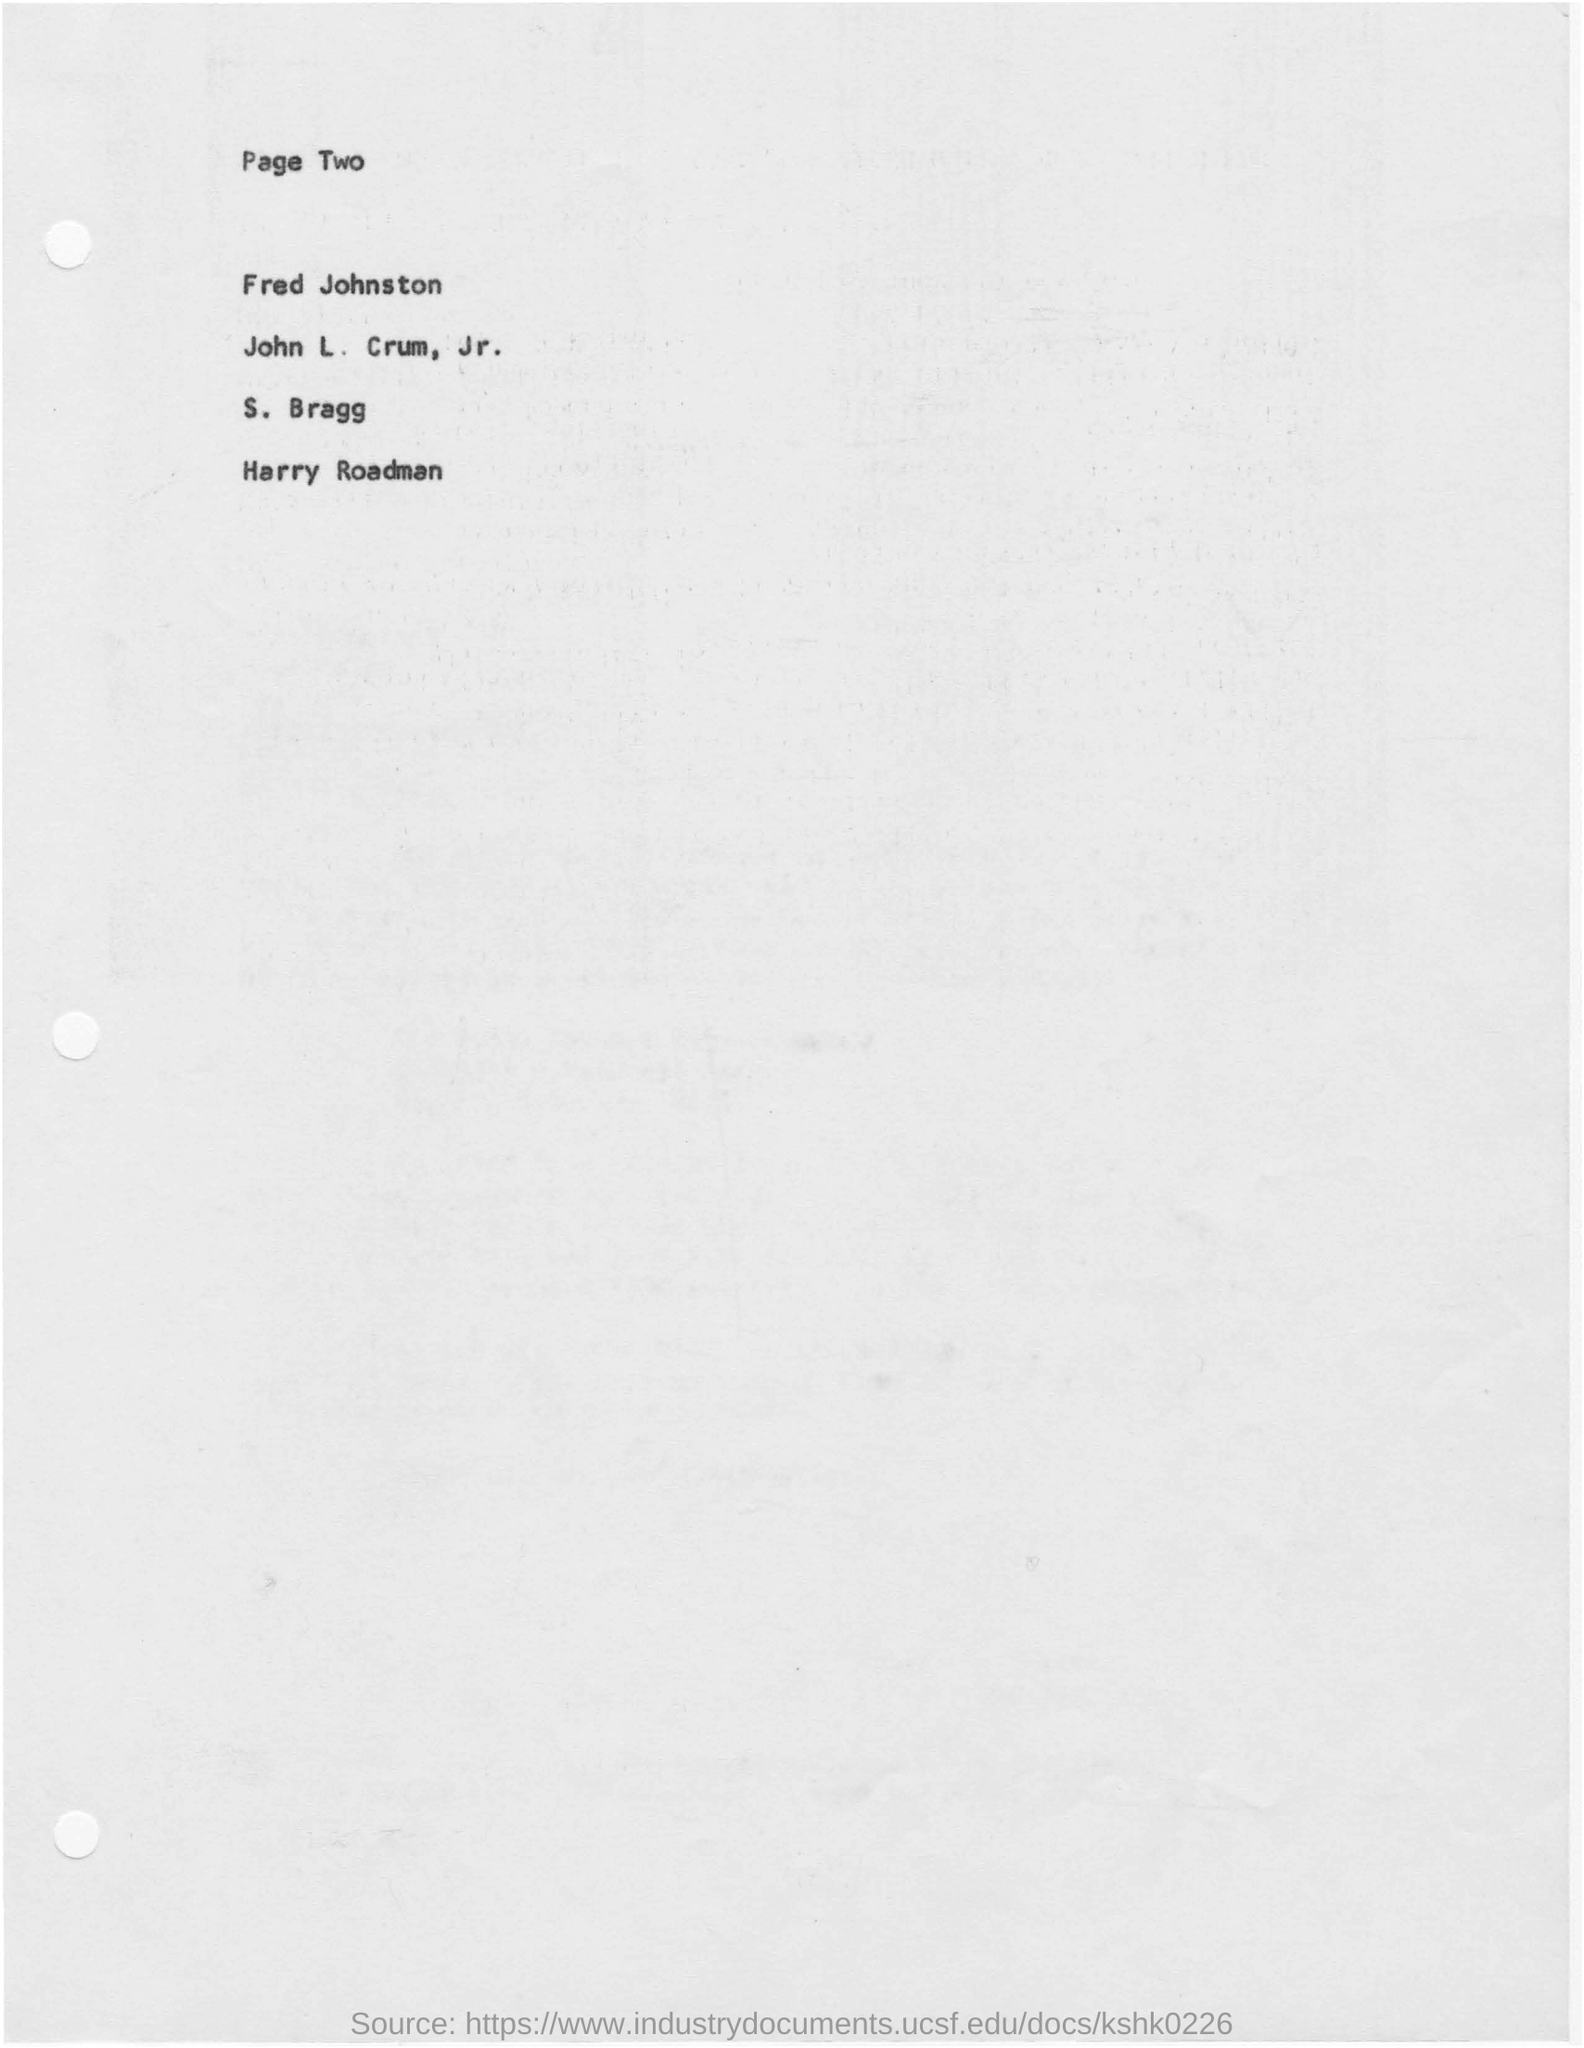What is the page no mentioned in this document?
Your answer should be very brief. Page Two. What is the first person's name in the list given?
Your response must be concise. Fred Johnston. What is the last person's name in the list given?
Provide a short and direct response. Harry Roadman. 